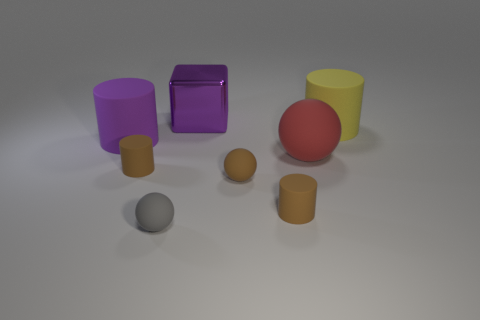Is there any other thing that has the same material as the purple block?
Provide a succinct answer. No. There is a object that is the same color as the metallic block; what is its material?
Offer a terse response. Rubber. What number of large rubber things are the same color as the metal cube?
Make the answer very short. 1. Does the cylinder behind the big purple cylinder have the same color as the small cylinder on the right side of the big purple shiny block?
Provide a succinct answer. No. There is a small gray sphere; are there any big blocks in front of it?
Offer a terse response. No. What is the material of the small gray ball?
Your answer should be very brief. Rubber. There is a tiny brown matte thing that is on the left side of the gray matte ball; what shape is it?
Offer a very short reply. Cylinder. There is a rubber cylinder that is the same color as the metallic object; what size is it?
Your answer should be very brief. Large. Are there any brown things that have the same size as the yellow cylinder?
Make the answer very short. No. Do the purple object to the left of the large metallic block and the big yellow object have the same material?
Your answer should be very brief. Yes. 